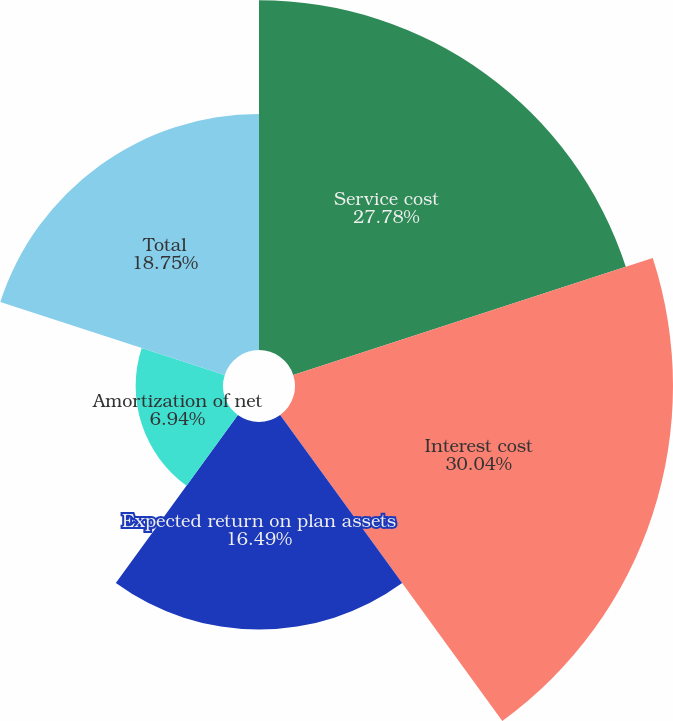<chart> <loc_0><loc_0><loc_500><loc_500><pie_chart><fcel>Service cost<fcel>Interest cost<fcel>Expected return on plan assets<fcel>Amortization of net<fcel>Total<nl><fcel>27.78%<fcel>30.03%<fcel>16.49%<fcel>6.94%<fcel>18.75%<nl></chart> 